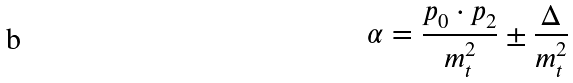<formula> <loc_0><loc_0><loc_500><loc_500>\alpha = \frac { p _ { 0 } \cdot p _ { 2 } } { m _ { t } ^ { 2 } } \pm \frac { \Delta } { m _ { t } ^ { 2 } }</formula> 